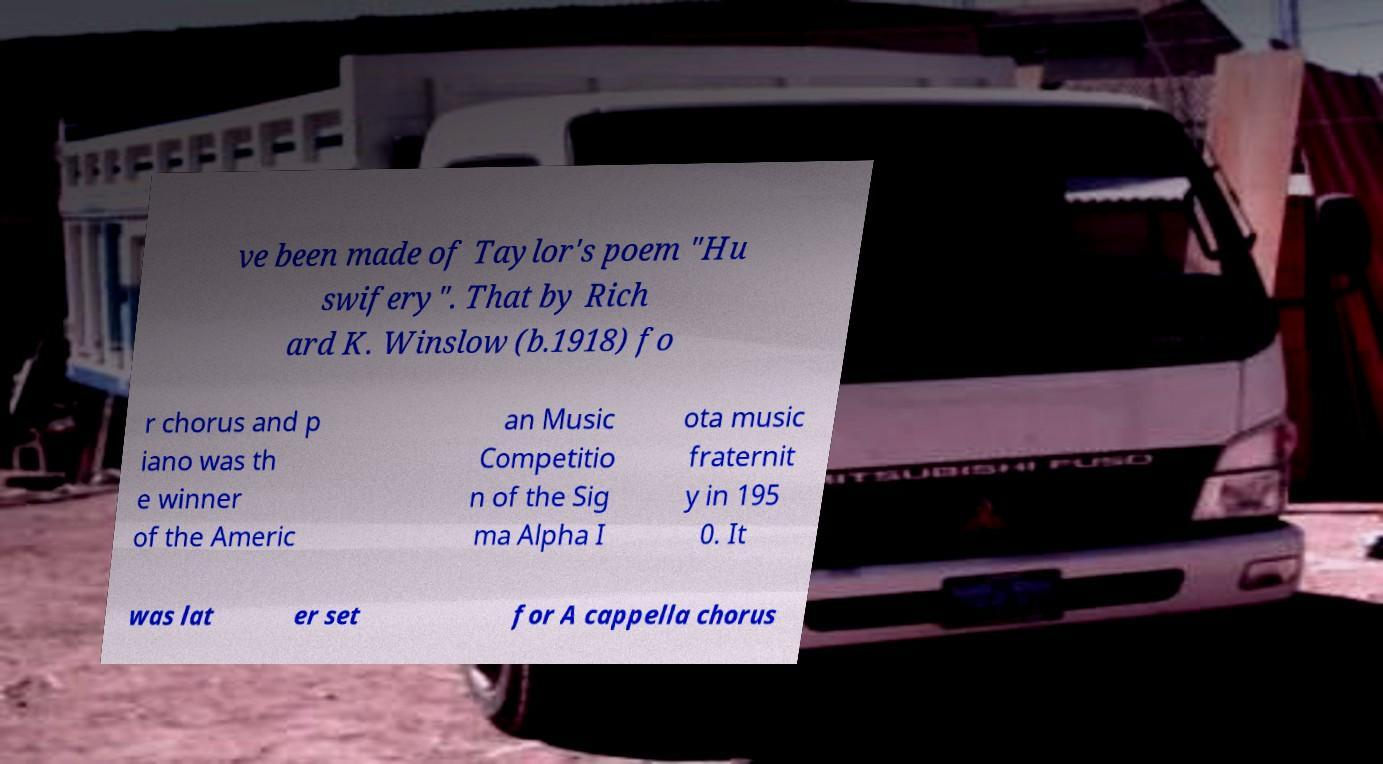What messages or text are displayed in this image? I need them in a readable, typed format. ve been made of Taylor's poem "Hu swifery". That by Rich ard K. Winslow (b.1918) fo r chorus and p iano was th e winner of the Americ an Music Competitio n of the Sig ma Alpha I ota music fraternit y in 195 0. It was lat er set for A cappella chorus 